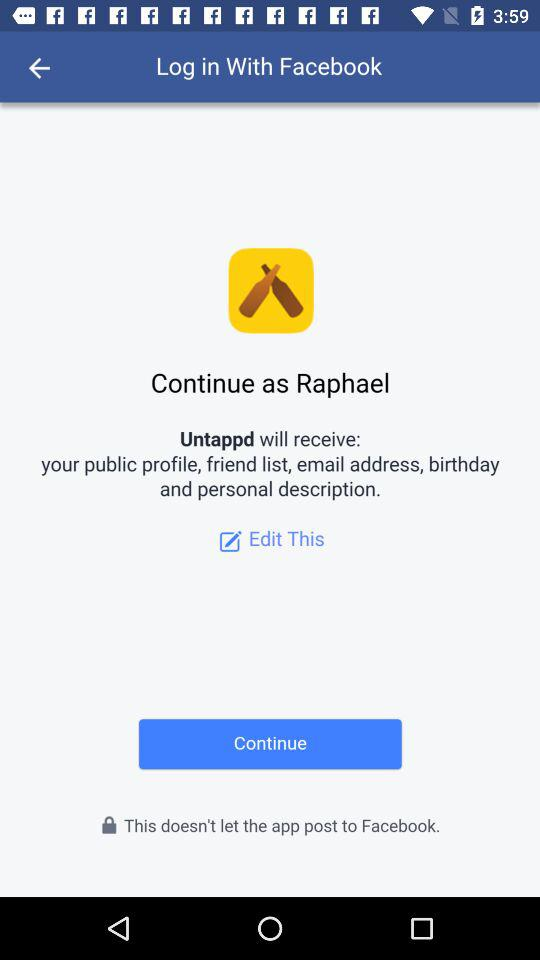Which application is asking for permission? The application is asking for permission is "Untappd". 